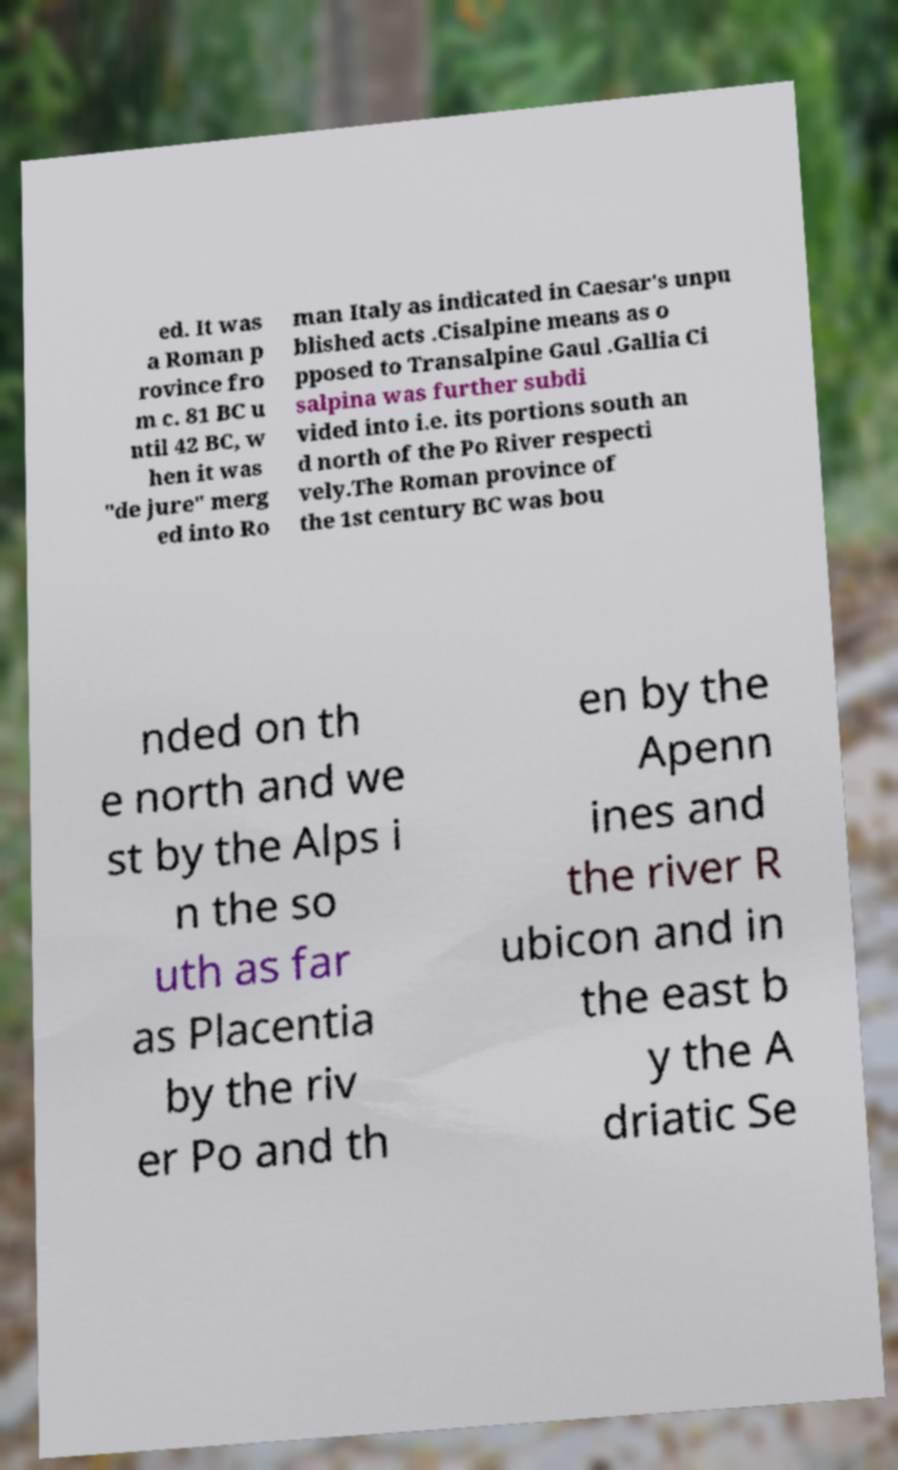Could you assist in decoding the text presented in this image and type it out clearly? ed. It was a Roman p rovince fro m c. 81 BC u ntil 42 BC, w hen it was "de jure" merg ed into Ro man Italy as indicated in Caesar's unpu blished acts .Cisalpine means as o pposed to Transalpine Gaul .Gallia Ci salpina was further subdi vided into i.e. its portions south an d north of the Po River respecti vely.The Roman province of the 1st century BC was bou nded on th e north and we st by the Alps i n the so uth as far as Placentia by the riv er Po and th en by the Apenn ines and the river R ubicon and in the east b y the A driatic Se 